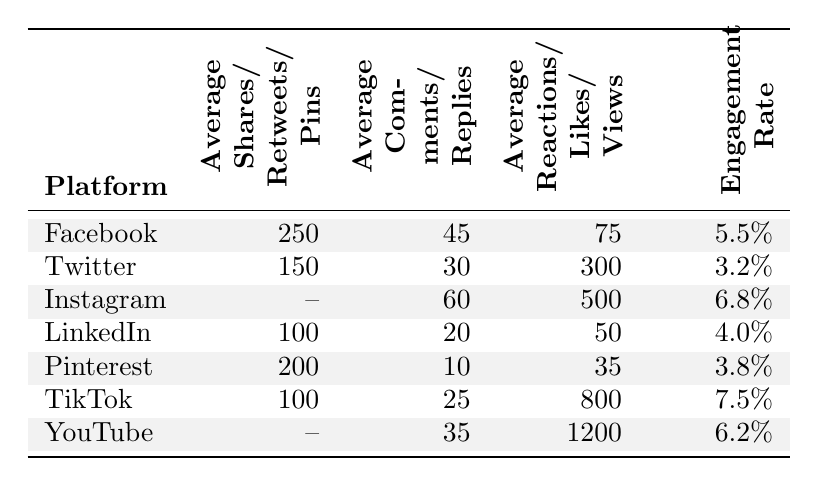What is the average engagement rate on Instagram? The table indicates that the engagement rate for Instagram is given explicitly as 6.8%.
Answer: 6.8% Which platform has the highest average likes? By examining the averages, TikTok has the highest average likes with 800, compared to the other platforms listed.
Answer: TikTok How many average comments does Pinterest receive? The table shows that Pinterest has an average of 10 comments.
Answer: 10 Which platform has a lower engagement rate, Twitter or LinkedIn? The engagement rate for Twitter is 3.2% and for LinkedIn, it is 4.0%. Since 3.2% is less than 4.0%, Twitter has the lower engagement rate.
Answer: Twitter Is the average number of shares on Facebook greater than the average number of shares on LinkedIn? Facebook has 250 shares and LinkedIn has 100 shares. Since 250 is greater than 100, the statement is true.
Answer: Yes What is the average number of reactions across all platforms? To find the average reactions, we would consider those available: Facebook (75), Twitter (300), Instagram (500), LinkedIn (50), Pinterest (35), TikTok (800), and YouTube (1200). The total is 75 + 300 + 500 + 50 + 35 + 800 + 1200 = 1960. There are four distinct platform types with reactions (excluding Instagram and TikTok). The average is 1960/6 = 326.67.
Answer: 326.67 Which platform has the lowest average comments? Pinterest, with an average of 10 comments, is the platform with the lowest average comments among those listed.
Answer: Pinterest What is the difference in average likes between TikTok and Twitter? TikTok has 800 average likes while Twitter has 300. The difference is 800 - 300 = 500.
Answer: 500 Is the engagement rate for TikTok higher than that of Instagram? TikTok has an engagement rate of 7.5%, and Instagram has 6.8%. Since 7.5% is greater than 6.8%, TikTok's engagement rate is higher.
Answer: Yes Which platform has the highest average comments? By comparison, Instagram has 60 average comments, which is higher than the other platforms listed.
Answer: Instagram 